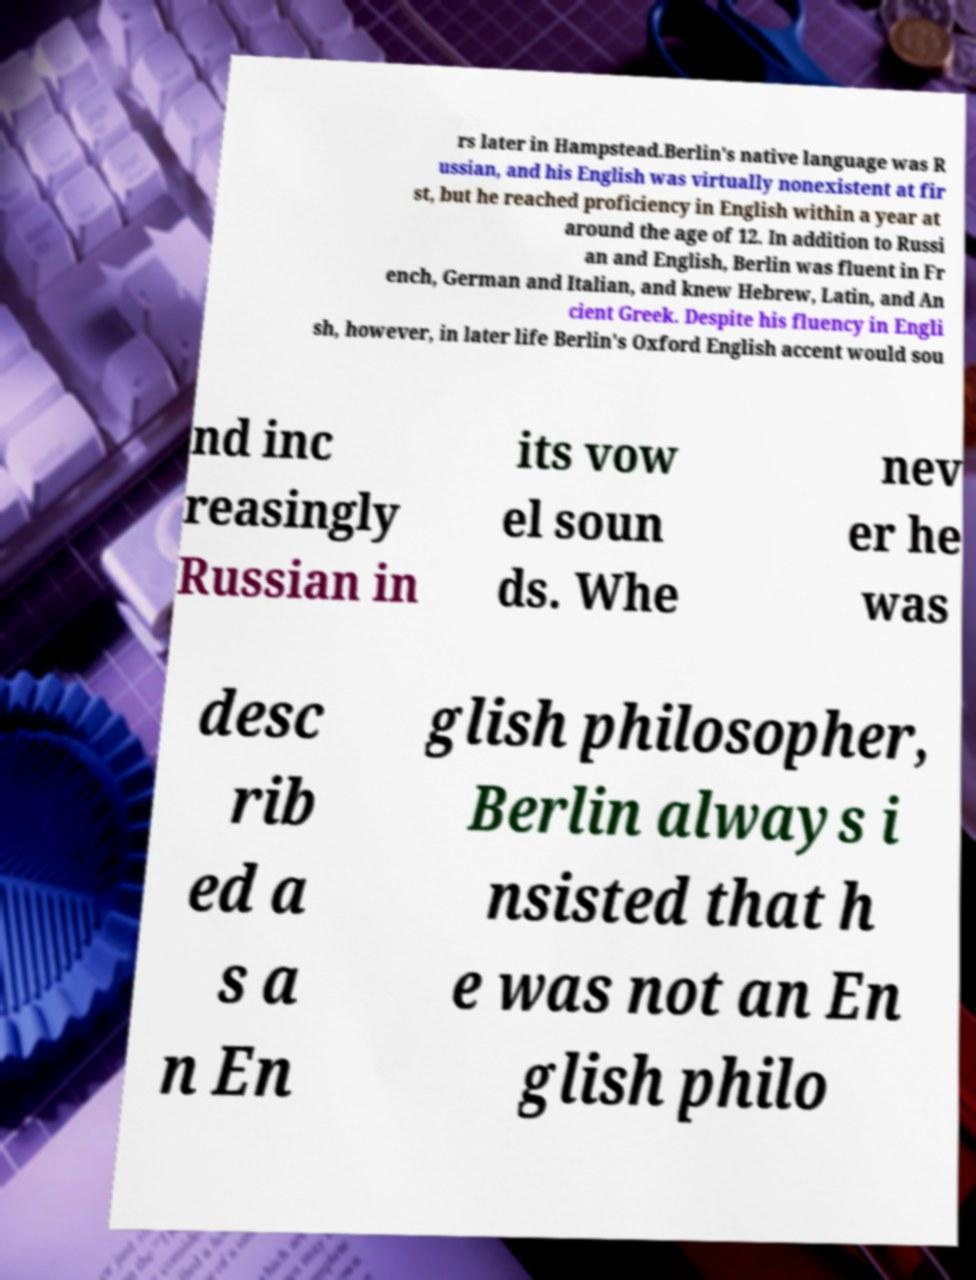Please read and relay the text visible in this image. What does it say? rs later in Hampstead.Berlin's native language was R ussian, and his English was virtually nonexistent at fir st, but he reached proficiency in English within a year at around the age of 12. In addition to Russi an and English, Berlin was fluent in Fr ench, German and Italian, and knew Hebrew, Latin, and An cient Greek. Despite his fluency in Engli sh, however, in later life Berlin's Oxford English accent would sou nd inc reasingly Russian in its vow el soun ds. Whe nev er he was desc rib ed a s a n En glish philosopher, Berlin always i nsisted that h e was not an En glish philo 